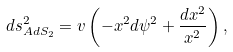<formula> <loc_0><loc_0><loc_500><loc_500>d s ^ { 2 } _ { A d S _ { 2 } } = v \left ( - x ^ { 2 } d \psi ^ { 2 } + \frac { d x ^ { 2 } } { x ^ { 2 } } \right ) ,</formula> 